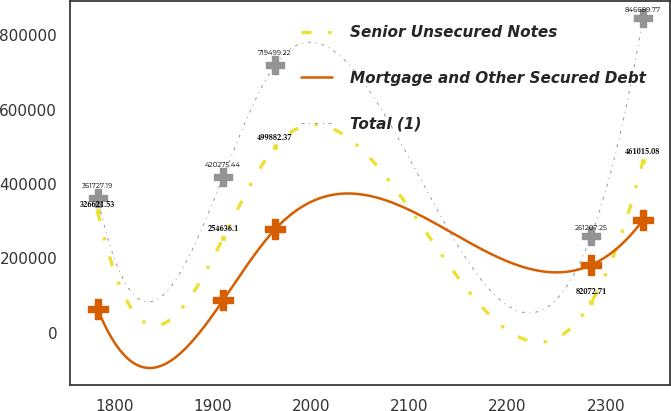<chart> <loc_0><loc_0><loc_500><loc_500><line_chart><ecel><fcel>Senior Unsecured Notes<fcel>Mortgage and Other Secured Debt<fcel>Total (1)<nl><fcel>1782.55<fcel>326622<fcel>63699<fcel>361727<nl><fcel>1910.38<fcel>254636<fcel>87631.9<fcel>420275<nl><fcel>1963.1<fcel>499882<fcel>277836<fcel>719499<nl><fcel>2285.03<fcel>82072.7<fcel>182188<fcel>261207<nl><fcel>2337.75<fcel>461015<fcel>303028<fcel>846690<nl></chart> 